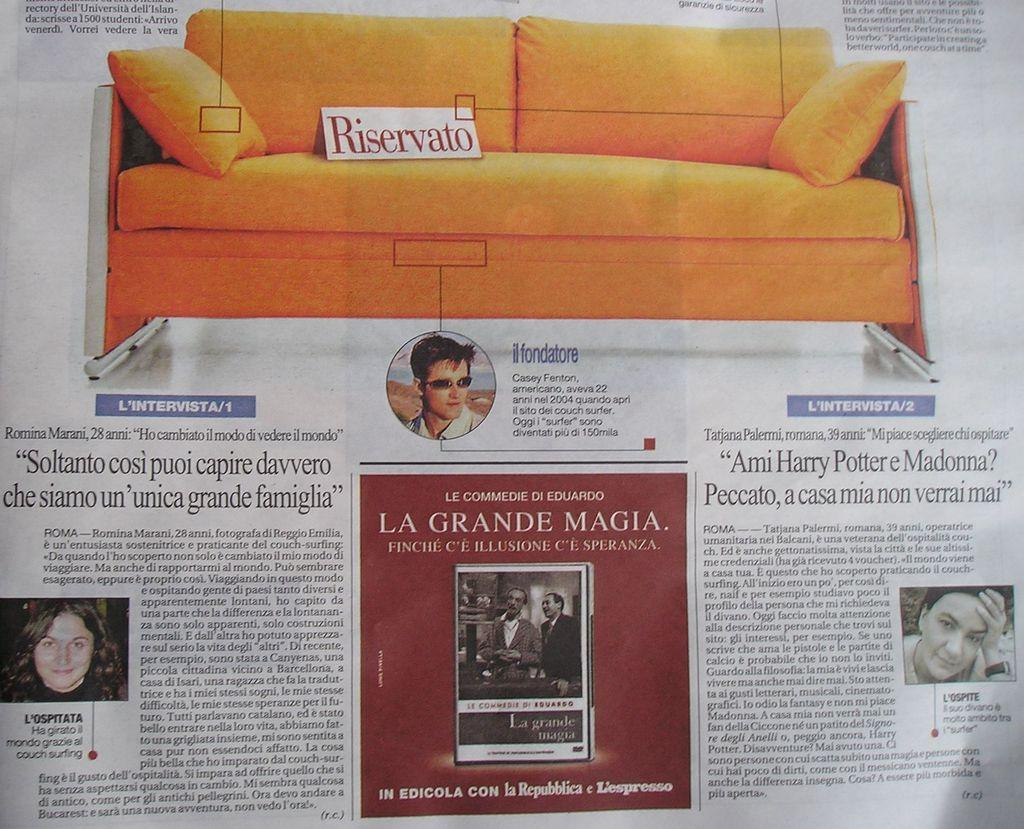What is the main object in the image? There is a paper in the image. What can be seen on the paper? The paper contains pictures of people and a sofa. Is there any text on the paper? Yes, there is writing on the paper. Can you tell me how many goats are depicted on the paper? There are no goats depicted on the paper; it features pictures of people and a sofa. What type of man is sitting on the cart in the image? There is no man sitting on a cart in the image; it only contains a paper with pictures of people and a sofa. 